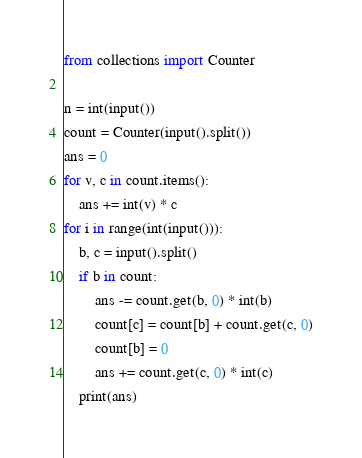<code> <loc_0><loc_0><loc_500><loc_500><_Python_>from collections import Counter

n = int(input())
count = Counter(input().split())
ans = 0
for v, c in count.items():
    ans += int(v) * c
for i in range(int(input())):
    b, c = input().split()
    if b in count:
        ans -= count.get(b, 0) * int(b)
        count[c] = count[b] + count.get(c, 0)
        count[b] = 0
        ans += count.get(c, 0) * int(c)
    print(ans)</code> 